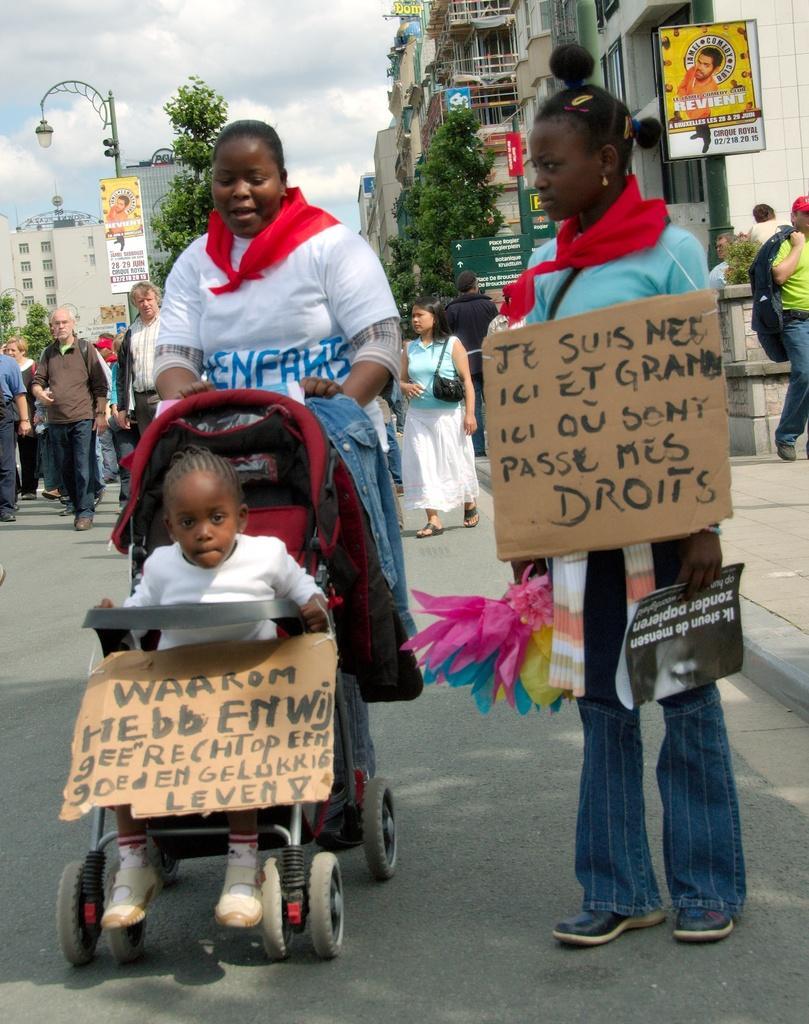Could you give a brief overview of what you see in this image? This picture is taken on the wide road. In this image, on the right side, we can see a woman standing and holding some objects in her hand and she is also wearing a card, on which is some text is written on it. In the middle of the image, we can see a woman standing and holding a bouncer, in the bouncer, we can see a kid and the kid is also holding a board in hand. In the background, we can see a group of people, street light, buildings, balcony. At the top, we can see a sky which is a bit cloudy, at the bottom, we can see a road and a footpath. 